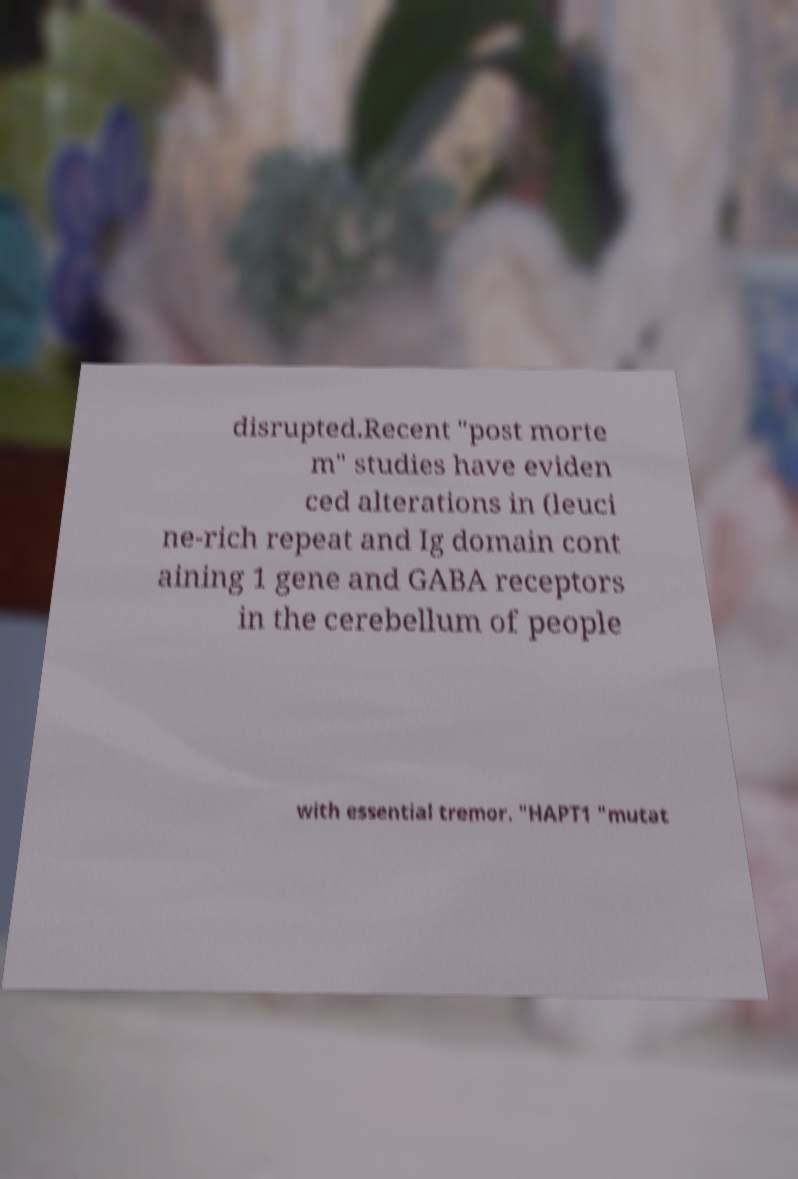I need the written content from this picture converted into text. Can you do that? disrupted.Recent "post morte m" studies have eviden ced alterations in (leuci ne-rich repeat and Ig domain cont aining 1 gene and GABA receptors in the cerebellum of people with essential tremor. "HAPT1 "mutat 